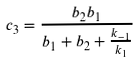<formula> <loc_0><loc_0><loc_500><loc_500>c _ { 3 } = \frac { b _ { 2 } b _ { 1 } } { b _ { 1 } + b _ { 2 } + \frac { k _ { - 1 } } { k _ { 1 } } }</formula> 